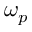<formula> <loc_0><loc_0><loc_500><loc_500>\omega _ { p }</formula> 